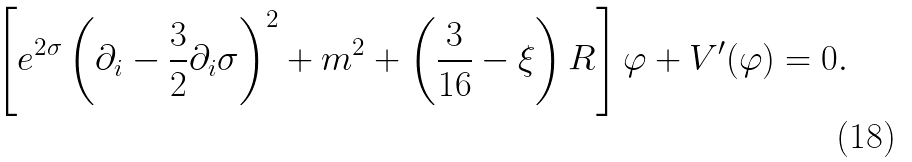<formula> <loc_0><loc_0><loc_500><loc_500>\left [ e ^ { 2 \sigma } \left ( \partial _ { i } - \frac { 3 } { 2 } \partial _ { i } \sigma \right ) ^ { 2 } + m ^ { 2 } + \left ( \frac { 3 } { 1 6 } - \xi \right ) R \right ] \varphi + V ^ { \prime } ( \varphi ) = 0 .</formula> 